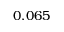<formula> <loc_0><loc_0><loc_500><loc_500>0 . 0 6 5</formula> 